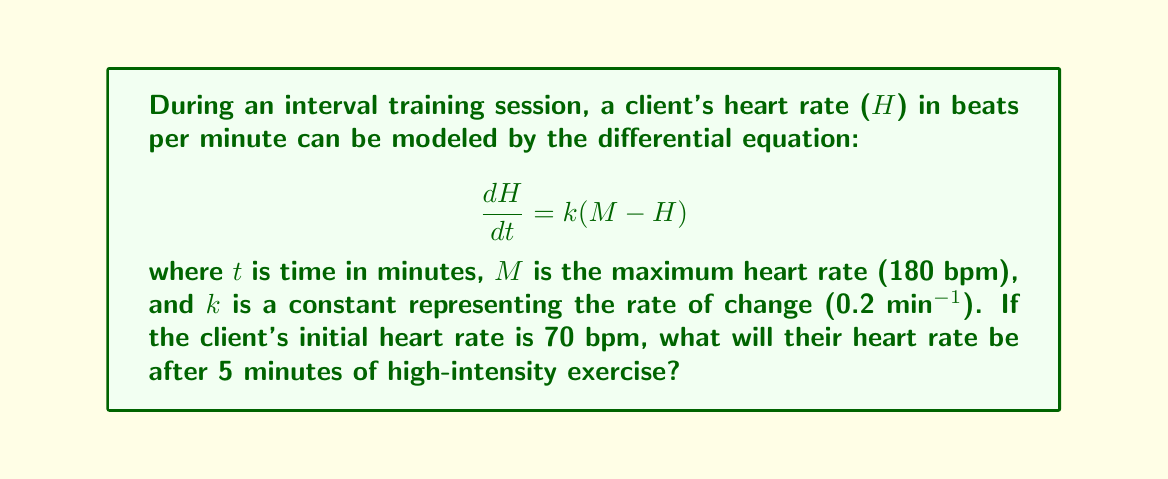What is the answer to this math problem? To solve this problem, we need to follow these steps:

1) The given differential equation is a first-order linear differential equation:

   $$\frac{dH}{dt} = k(M - H)$$

2) We can solve this by separating variables:

   $$\frac{dH}{M - H} = k dt$$

3) Integrating both sides:

   $$-\ln|M - H| = kt + C$$

4) Solving for H:

   $$H = M - Ae^{-kt}$$

   where A is a constant of integration.

5) Using the initial condition H(0) = 70, we can find A:

   $$70 = 180 - A$$
   $$A = 110$$

6) So our particular solution is:

   $$H = 180 - 110e^{-0.2t}$$

7) To find H at t = 5 minutes:

   $$H(5) = 180 - 110e^{-0.2(5)}$$
   $$= 180 - 110e^{-1}$$
   $$\approx 139.5$$

8) Rounding to the nearest whole number (as heart rate is typically measured):

   $$H(5) \approx 140 \text{ bpm}$$
Answer: 140 bpm 